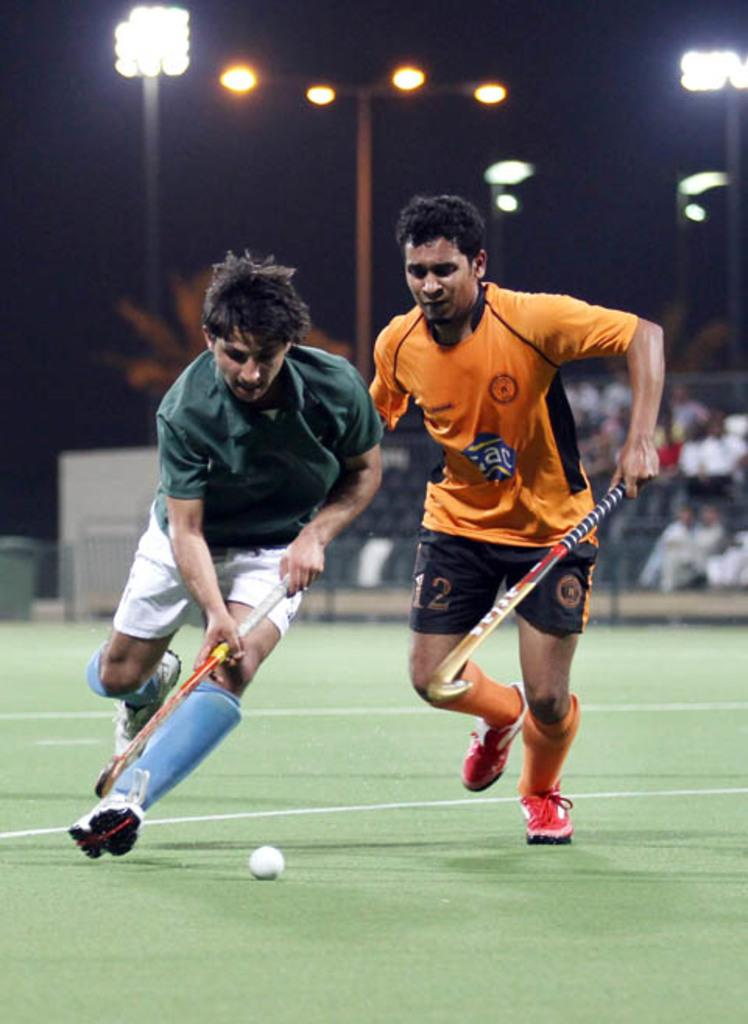Provide a one-sentence caption for the provided image. Two lacross players, one of them with black shorts with the number 12 written on them. 